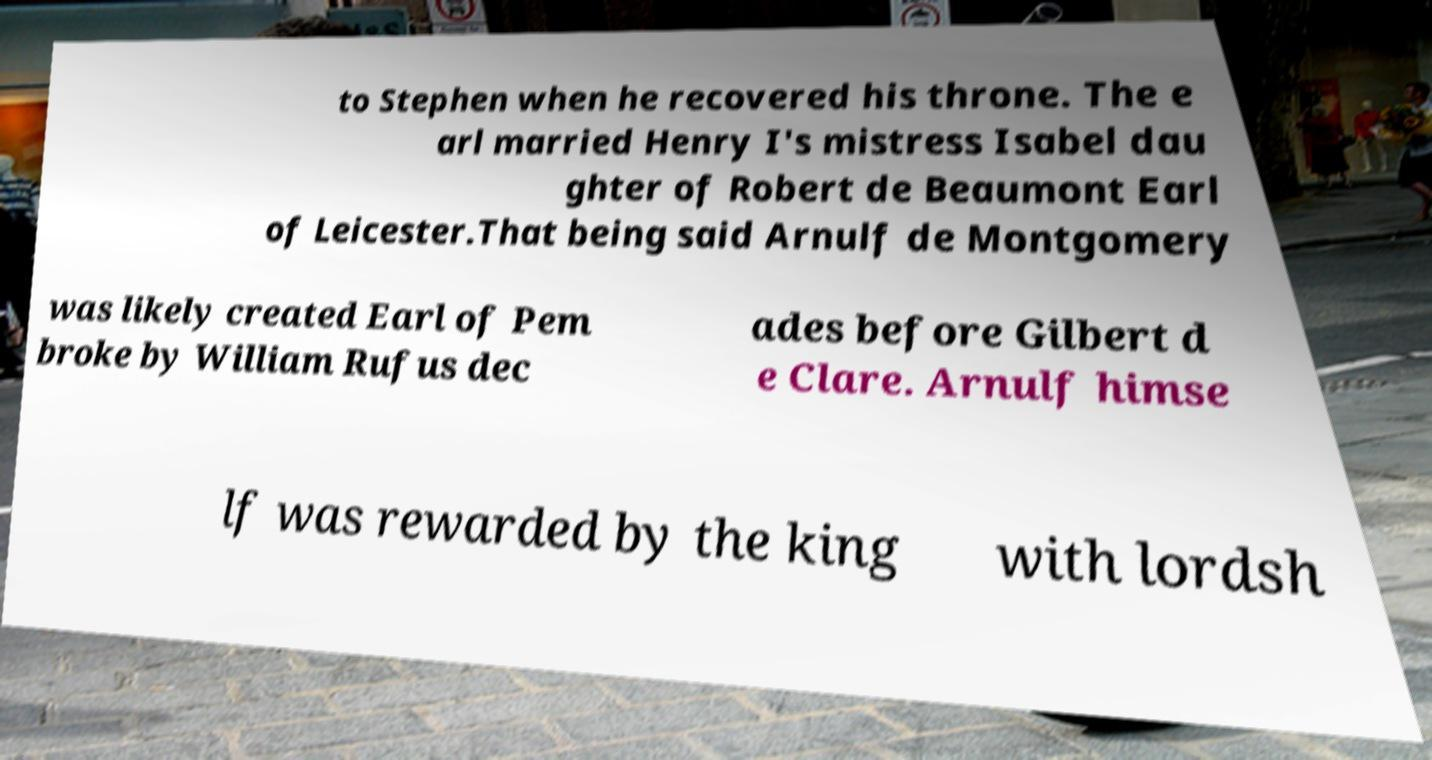I need the written content from this picture converted into text. Can you do that? to Stephen when he recovered his throne. The e arl married Henry I's mistress Isabel dau ghter of Robert de Beaumont Earl of Leicester.That being said Arnulf de Montgomery was likely created Earl of Pem broke by William Rufus dec ades before Gilbert d e Clare. Arnulf himse lf was rewarded by the king with lordsh 